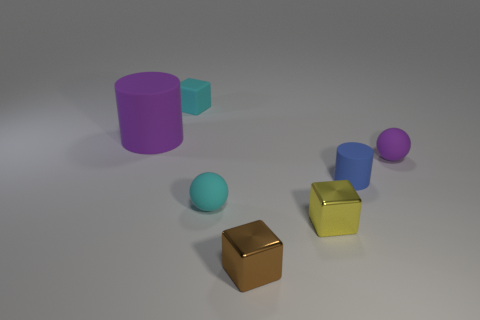What materials do the objects look like they are made of? The objects appear to be rendered with different materials. The cylinders and the sphere seem to have a matte rubber-like texture, while the cubes look metallic with a reflective surface. 